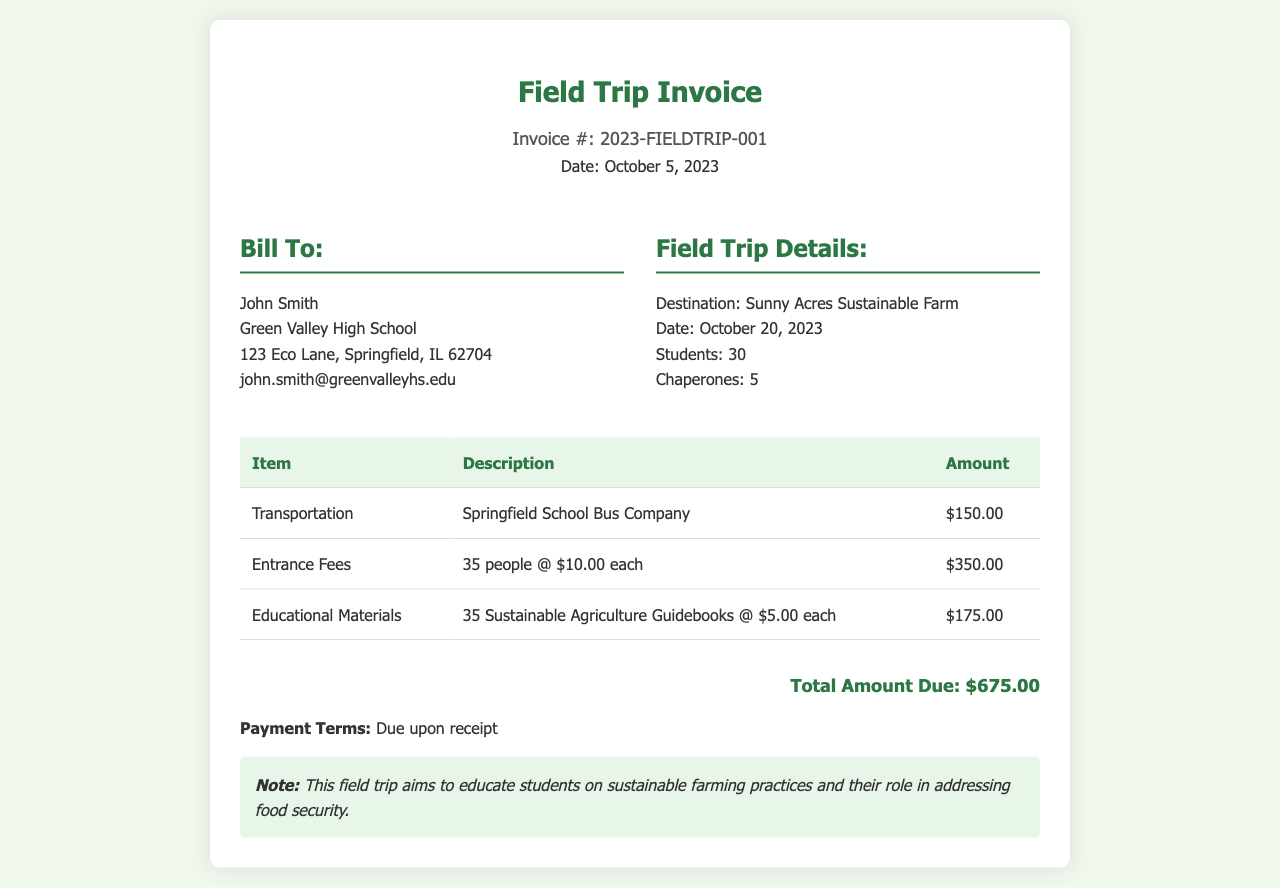What is the invoice number? The invoice number is listed at the top of the document as a unique identifier for the invoice, which is 2023-FIELDTRIP-001.
Answer: 2023-FIELDTRIP-001 What is the total amount due? The total amount due is summarized at the end of the invoice, which aggregates all costs related to the field trip.
Answer: $675.00 How many students are attending the field trip? The number of students is mentioned in the field trip details section, explicitly stating the quantity of participants.
Answer: 30 What is the date of the field trip? The date of the field trip is clearly indicated in the field trip details section, which specifies when the trip will occur.
Answer: October 20, 2023 What company is providing transportation? The transportation provider is specified in the table, giving clear identification of who is responsible for this service.
Answer: Springfield School Bus Company How many chaperones are accompanying the students? The information about the number of chaperones is provided in the field trip details section, showing the supervision arrangement for the trip.
Answer: 5 What is the cost per entrance fee? The cost per entrance fee is outlined in the itemized list of expenses, specifying the fee charged per individual for entry.
Answer: $10.00 What is included in the educational materials? The educational materials are detailed in the invoice's itemized list, where specific items provided to enhance education are mentioned.
Answer: 35 Sustainable Agriculture Guidebooks What is the payment term? The payment terms are described at the end of the invoice, indicating when payment should be made in relation to receipt of the invoice.
Answer: Due upon receipt 